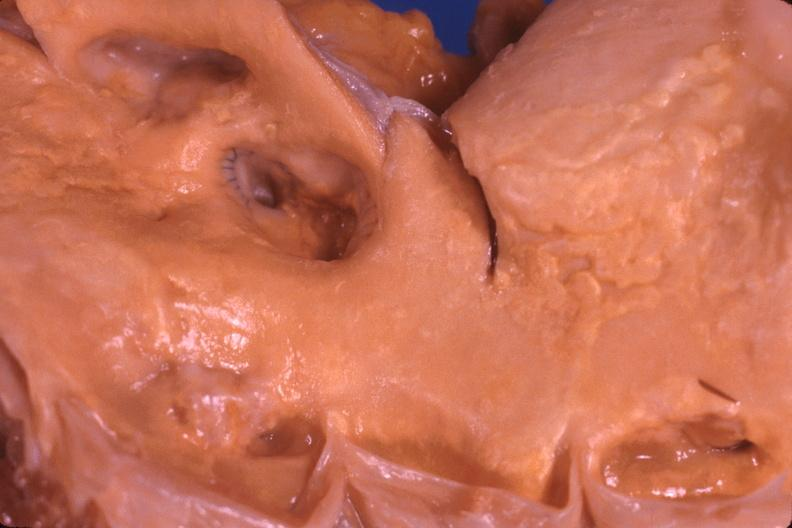does this image show saphenous vein graft anastamosis in aorta?
Answer the question using a single word or phrase. Yes 